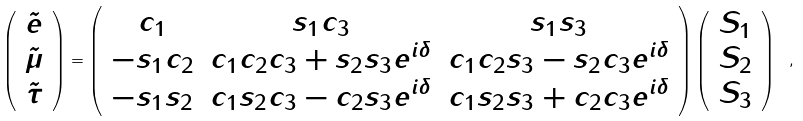Convert formula to latex. <formula><loc_0><loc_0><loc_500><loc_500>\left ( \begin{array} { c } { { \tilde { e } } } \\ { { \tilde { \mu } } } \\ { { \tilde { \tau } } } \end{array} \right ) = \left ( \begin{array} { c c c } { { c _ { 1 } } } & { { s _ { 1 } c _ { 3 } } } & { { s _ { 1 } s _ { 3 } } } \\ { { - s _ { 1 } c _ { 2 } } } & { { c _ { 1 } c _ { 2 } c _ { 3 } + s _ { 2 } s _ { 3 } e ^ { i \delta } } } & { { c _ { 1 } c _ { 2 } s _ { 3 } - s _ { 2 } c _ { 3 } e ^ { i \delta } } } \\ { { - s _ { 1 } s _ { 2 } } } & { { c _ { 1 } s _ { 2 } c _ { 3 } - c _ { 2 } s _ { 3 } e ^ { i \delta } } } & { { c _ { 1 } s _ { 2 } s _ { 3 } + c _ { 2 } c _ { 3 } e ^ { i \delta } } } \end{array} \right ) \left ( \begin{array} { c } { { S _ { 1 } } } \\ { { S _ { 2 } } } \\ { { S _ { 3 } } } \end{array} \right ) \ ,</formula> 